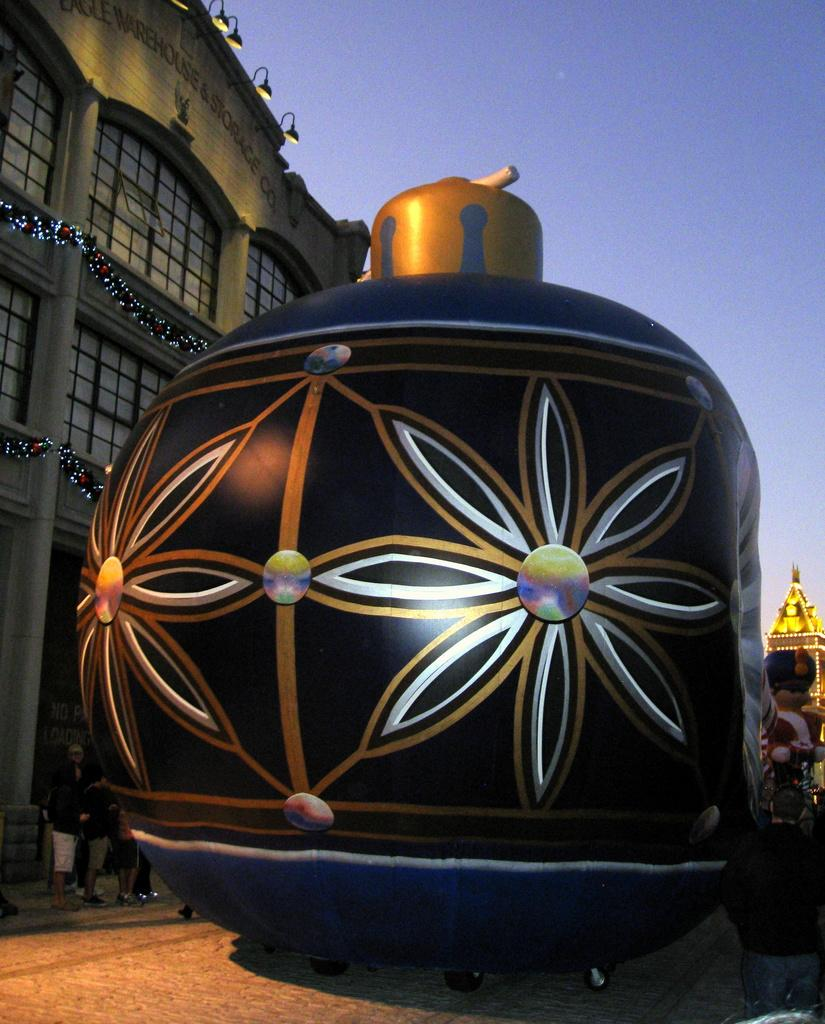What is the color of the object in the image? The object in the image is black. What can be seen in the background of the image? There are people standing in the background of the image. What is illuminated in the image? There are lights visible in the image. What is the color of the building in the image? The building in the image has a cream color. What is the color of the sky in the image? The sky is blue in the image. What type of cake is being served in the image? There is no cake present in the image. What statement is being made by the object in the image? The object in the image is not making a statement; it is simply an object with a black color. 